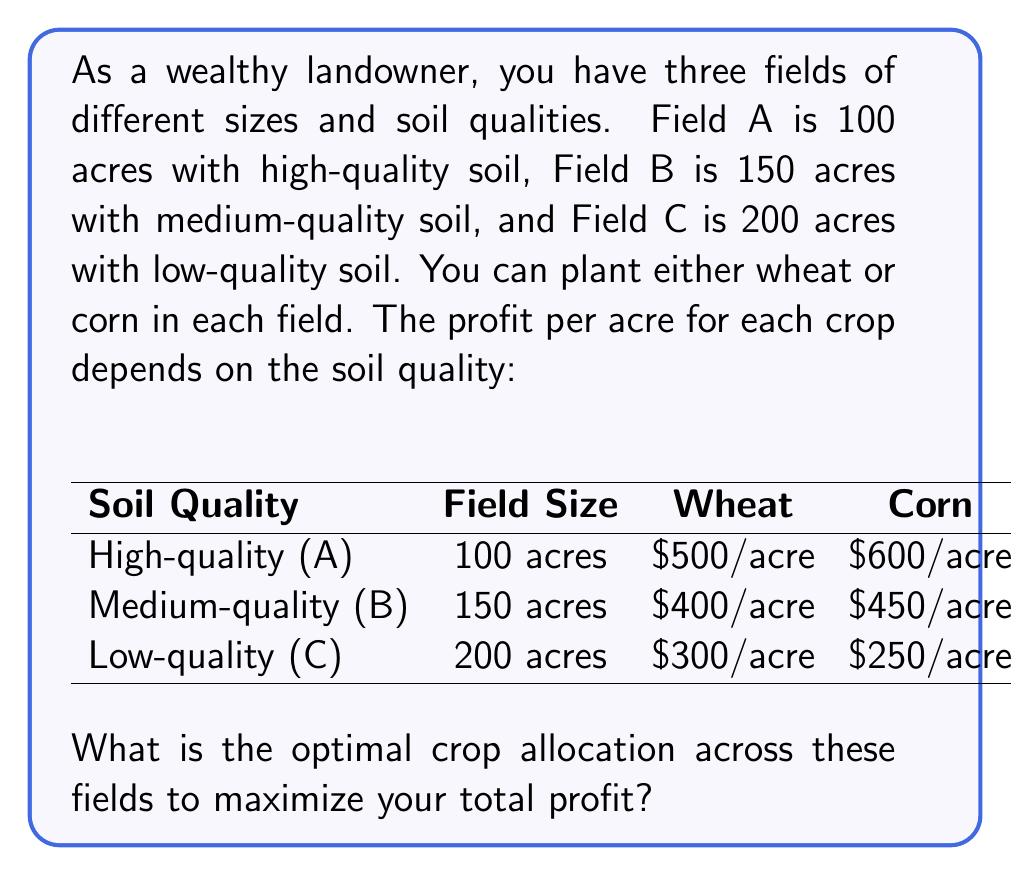Can you solve this math problem? To determine the optimal crop allocation, we need to compare the profit potential for each field:

1. Field A (100 acres, high-quality soil):
   Wheat: $500/acre
   Corn: $600/acre
   Optimal choice: Corn (higher profit)

2. Field B (150 acres, medium-quality soil):
   Wheat: $400/acre
   Corn: $450/acre
   Optimal choice: Corn (higher profit)

3. Field C (200 acres, low-quality soil):
   Wheat: $300/acre
   Corn: $250/acre
   Optimal choice: Wheat (higher profit)

Now, let's calculate the maximum profit:

Field A: 100 acres × $600/acre = $60,000 (Corn)
Field B: 150 acres × $450/acre = $67,500 (Corn)
Field C: 200 acres × $300/acre = $60,000 (Wheat)

Total maximum profit: $60,000 + $67,500 + $60,000 = $187,500

The optimal allocation is:
- Field A: 100 acres of Corn
- Field B: 150 acres of Corn
- Field C: 200 acres of Wheat
Answer: Field A: 100 acres Corn, Field B: 150 acres Corn, Field C: 200 acres Wheat; Total profit: $187,500 